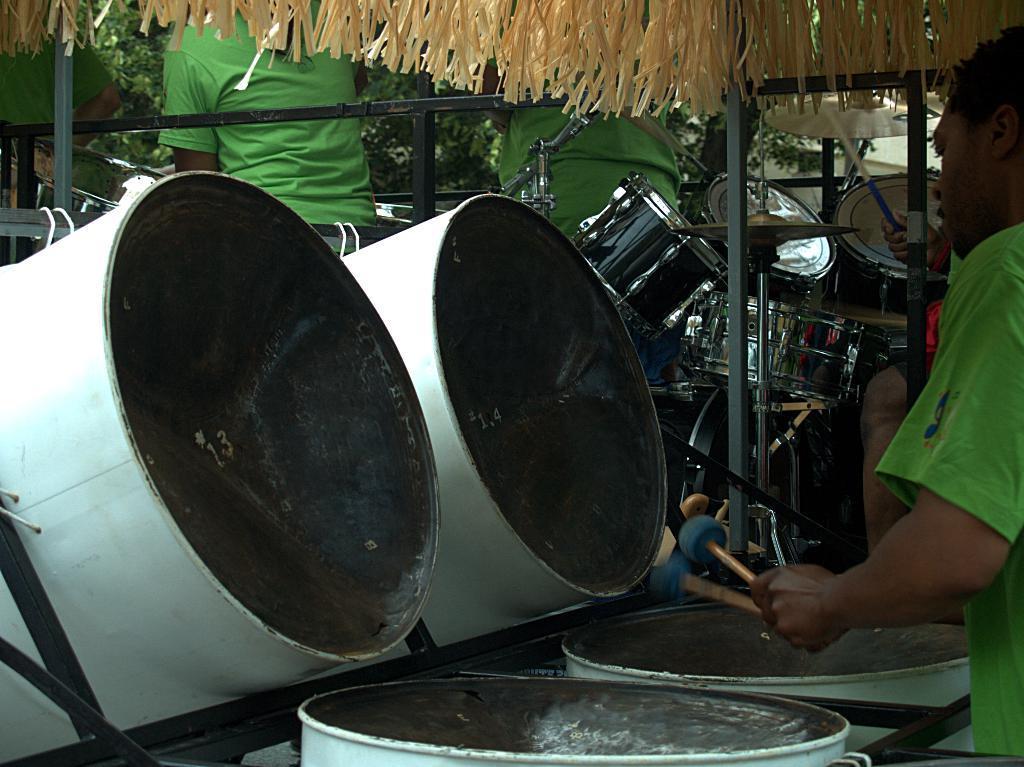In one or two sentences, can you explain what this image depicts? There are two persons playing the drums as we can see on the right side of this image. There are two persons standing at the top of this image, and there are some trees in the background. 